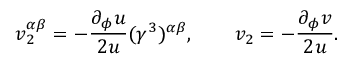Convert formula to latex. <formula><loc_0><loc_0><loc_500><loc_500>v _ { 2 } ^ { \alpha \beta } = - \frac { \partial _ { \phi } u } { 2 u } ( \gamma ^ { 3 } ) ^ { \alpha \beta } , \quad v _ { 2 } = - \frac { \partial _ { \phi } v } { 2 u } .</formula> 